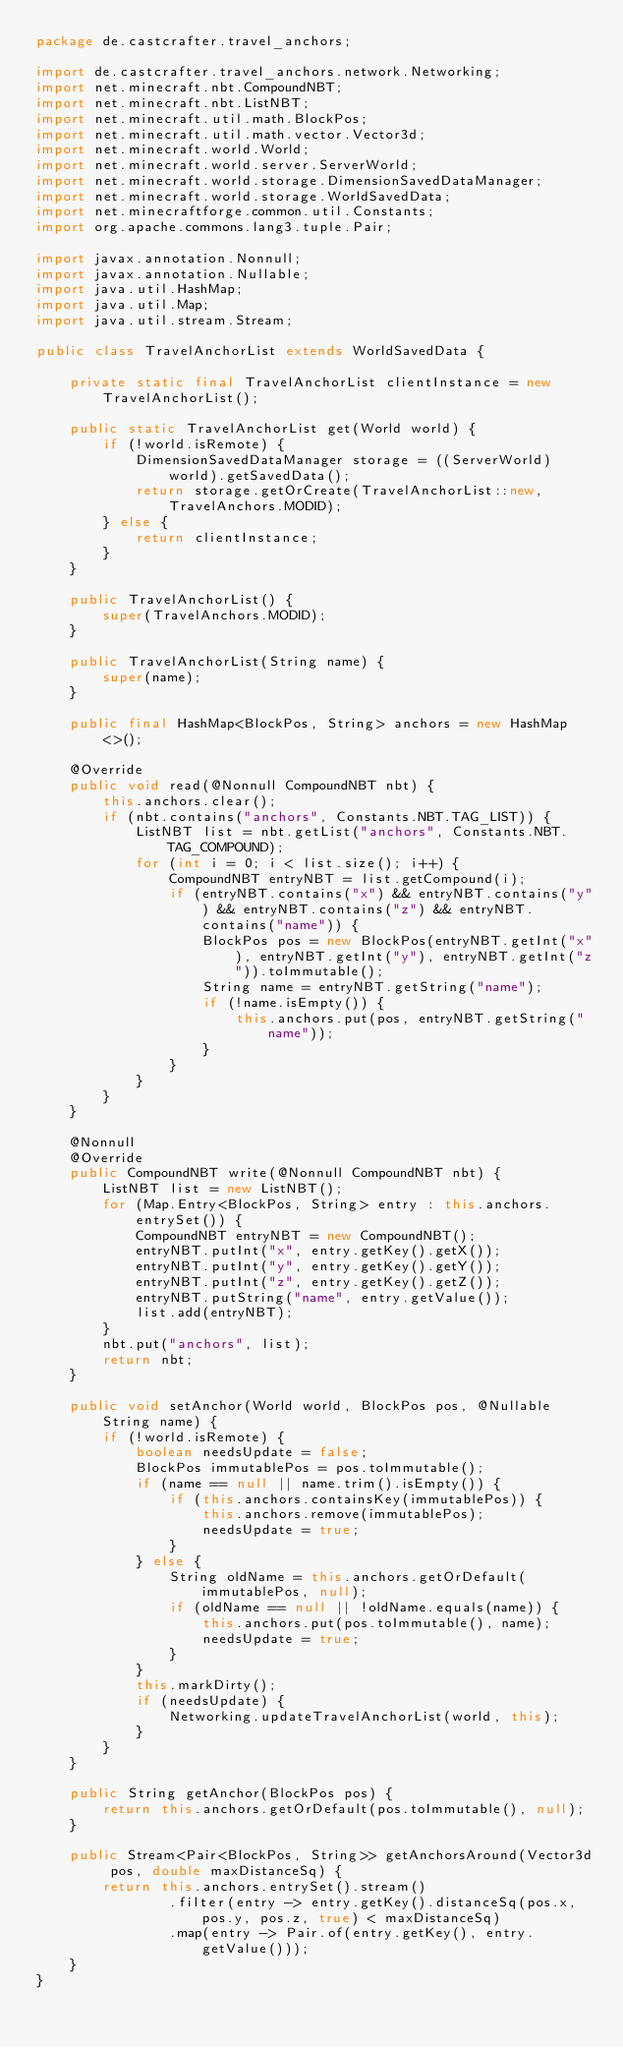Convert code to text. <code><loc_0><loc_0><loc_500><loc_500><_Java_>package de.castcrafter.travel_anchors;

import de.castcrafter.travel_anchors.network.Networking;
import net.minecraft.nbt.CompoundNBT;
import net.minecraft.nbt.ListNBT;
import net.minecraft.util.math.BlockPos;
import net.minecraft.util.math.vector.Vector3d;
import net.minecraft.world.World;
import net.minecraft.world.server.ServerWorld;
import net.minecraft.world.storage.DimensionSavedDataManager;
import net.minecraft.world.storage.WorldSavedData;
import net.minecraftforge.common.util.Constants;
import org.apache.commons.lang3.tuple.Pair;

import javax.annotation.Nonnull;
import javax.annotation.Nullable;
import java.util.HashMap;
import java.util.Map;
import java.util.stream.Stream;

public class TravelAnchorList extends WorldSavedData {

    private static final TravelAnchorList clientInstance = new TravelAnchorList();

    public static TravelAnchorList get(World world) {
        if (!world.isRemote) {
            DimensionSavedDataManager storage = ((ServerWorld) world).getSavedData();
            return storage.getOrCreate(TravelAnchorList::new, TravelAnchors.MODID);
        } else {
            return clientInstance;
        }
    }

    public TravelAnchorList() {
        super(TravelAnchors.MODID);
    }

    public TravelAnchorList(String name) {
        super(name);
    }

    public final HashMap<BlockPos, String> anchors = new HashMap<>();

    @Override
    public void read(@Nonnull CompoundNBT nbt) {
        this.anchors.clear();
        if (nbt.contains("anchors", Constants.NBT.TAG_LIST)) {
            ListNBT list = nbt.getList("anchors", Constants.NBT.TAG_COMPOUND);
            for (int i = 0; i < list.size(); i++) {
                CompoundNBT entryNBT = list.getCompound(i);
                if (entryNBT.contains("x") && entryNBT.contains("y") && entryNBT.contains("z") && entryNBT.contains("name")) {
                    BlockPos pos = new BlockPos(entryNBT.getInt("x"), entryNBT.getInt("y"), entryNBT.getInt("z")).toImmutable();
                    String name = entryNBT.getString("name");
                    if (!name.isEmpty()) {
                        this.anchors.put(pos, entryNBT.getString("name"));
                    }
                }
            }
        }
    }

    @Nonnull
    @Override
    public CompoundNBT write(@Nonnull CompoundNBT nbt) {
        ListNBT list = new ListNBT();
        for (Map.Entry<BlockPos, String> entry : this.anchors.entrySet()) {
            CompoundNBT entryNBT = new CompoundNBT();
            entryNBT.putInt("x", entry.getKey().getX());
            entryNBT.putInt("y", entry.getKey().getY());
            entryNBT.putInt("z", entry.getKey().getZ());
            entryNBT.putString("name", entry.getValue());
            list.add(entryNBT);
        }
        nbt.put("anchors", list);
        return nbt;
    }

    public void setAnchor(World world, BlockPos pos, @Nullable String name) {
        if (!world.isRemote) {
            boolean needsUpdate = false;
            BlockPos immutablePos = pos.toImmutable();
            if (name == null || name.trim().isEmpty()) {
                if (this.anchors.containsKey(immutablePos)) {
                    this.anchors.remove(immutablePos);
                    needsUpdate = true;
                }
            } else {
                String oldName = this.anchors.getOrDefault(immutablePos, null);
                if (oldName == null || !oldName.equals(name)) {
                    this.anchors.put(pos.toImmutable(), name);
                    needsUpdate = true;
                }
            }
            this.markDirty();
            if (needsUpdate) {
                Networking.updateTravelAnchorList(world, this);
            }
        }
    }

    public String getAnchor(BlockPos pos) {
        return this.anchors.getOrDefault(pos.toImmutable(), null);
    }

    public Stream<Pair<BlockPos, String>> getAnchorsAround(Vector3d pos, double maxDistanceSq) {
        return this.anchors.entrySet().stream()
                .filter(entry -> entry.getKey().distanceSq(pos.x, pos.y, pos.z, true) < maxDistanceSq)
                .map(entry -> Pair.of(entry.getKey(), entry.getValue()));
    }
}

</code> 